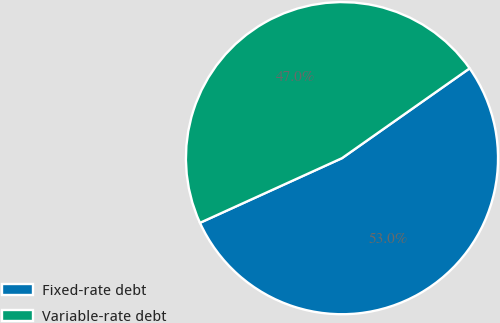Convert chart to OTSL. <chart><loc_0><loc_0><loc_500><loc_500><pie_chart><fcel>Fixed-rate debt<fcel>Variable-rate debt<nl><fcel>52.96%<fcel>47.04%<nl></chart> 